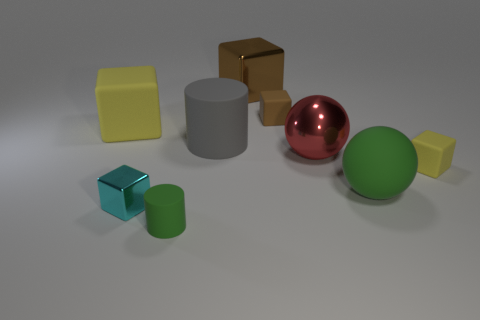Which object stands out the most to you? The red sphere stands out due to its vibrant color and reflective surface, contrasting with the other objects that have either more subdued colors or non-reflective surfaces. 